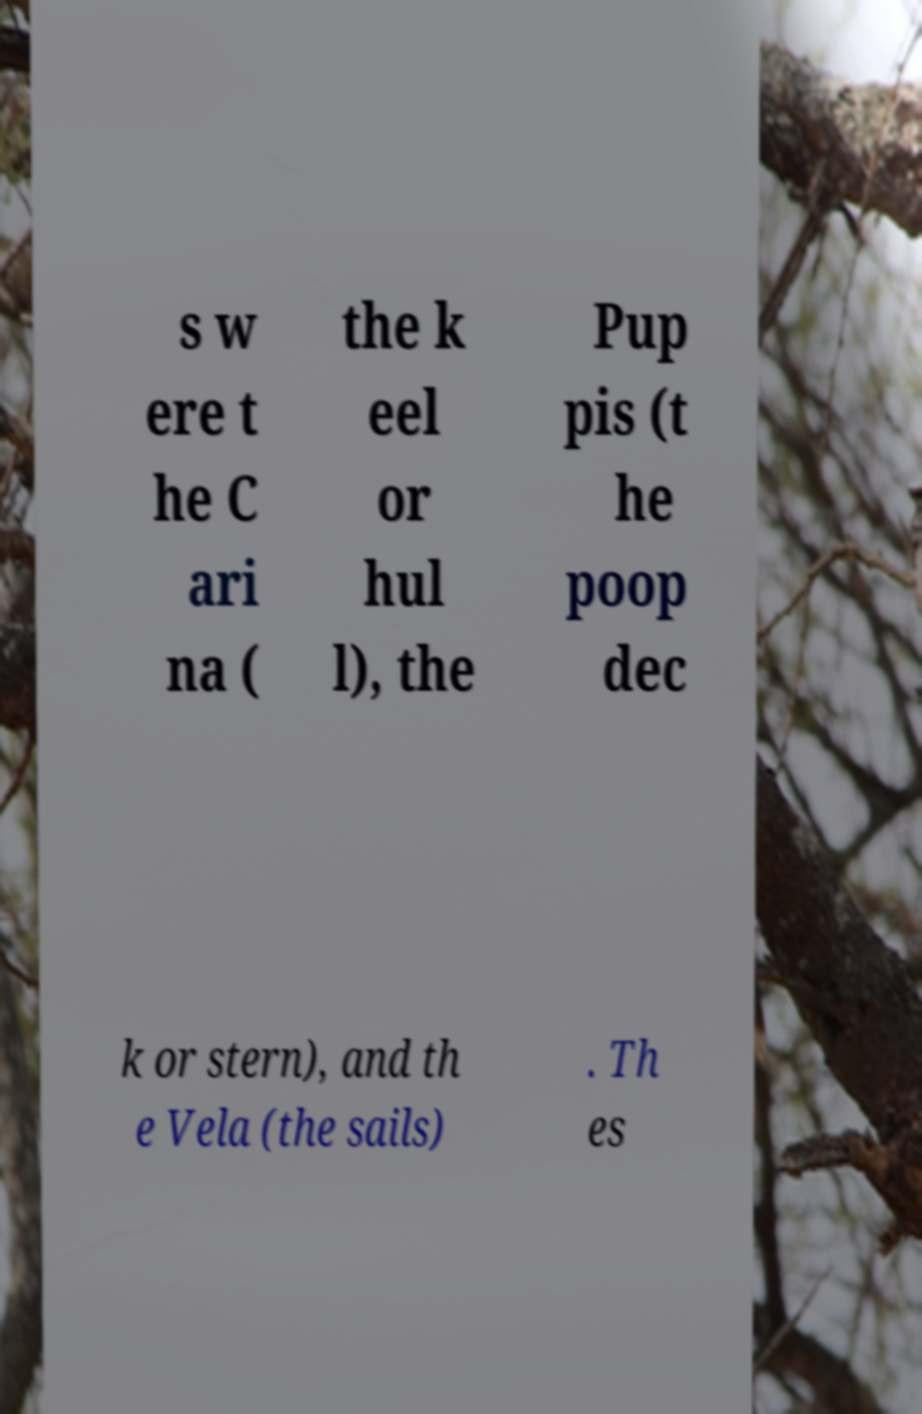Could you extract and type out the text from this image? s w ere t he C ari na ( the k eel or hul l), the Pup pis (t he poop dec k or stern), and th e Vela (the sails) . Th es 